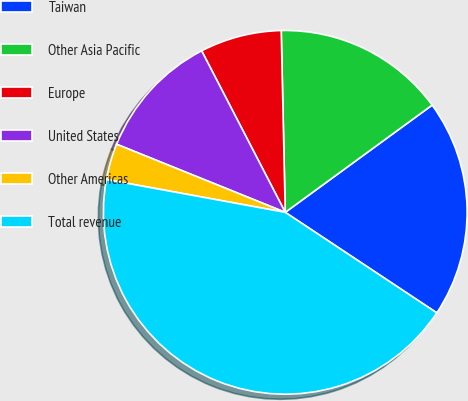Convert chart. <chart><loc_0><loc_0><loc_500><loc_500><pie_chart><fcel>Taiwan<fcel>Other Asia Pacific<fcel>Europe<fcel>United States<fcel>Other Americas<fcel>Total revenue<nl><fcel>19.36%<fcel>15.32%<fcel>7.25%<fcel>11.29%<fcel>3.22%<fcel>43.57%<nl></chart> 